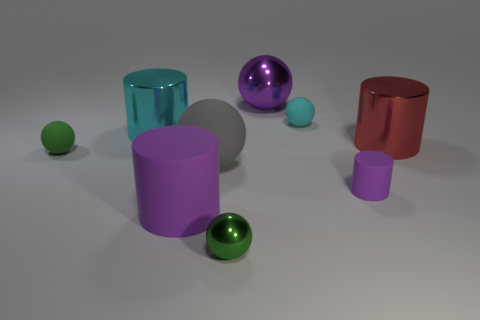Is there another thing that has the same color as the small metallic thing?
Make the answer very short. Yes. What number of other objects are there of the same color as the tiny matte cylinder?
Offer a very short reply. 2. What number of other small balls have the same color as the tiny shiny sphere?
Offer a terse response. 1. The other metal thing that is the same shape as the large red shiny thing is what color?
Keep it short and to the point. Cyan. There is a large shiny thing that is in front of the purple sphere and on the right side of the gray object; what is its shape?
Keep it short and to the point. Cylinder. Are there more purple objects than small cyan rubber objects?
Ensure brevity in your answer.  Yes. What material is the big purple ball?
Make the answer very short. Metal. There is another purple object that is the same shape as the tiny shiny thing; what size is it?
Give a very brief answer. Large. Is there a shiny cylinder that is right of the tiny cyan matte thing that is in front of the large metallic ball?
Ensure brevity in your answer.  Yes. Is the color of the large matte ball the same as the big metal sphere?
Ensure brevity in your answer.  No. 